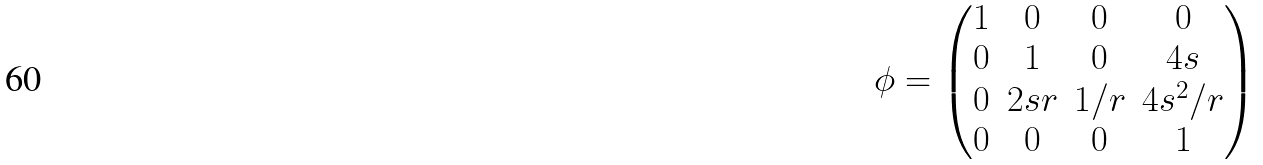Convert formula to latex. <formula><loc_0><loc_0><loc_500><loc_500>\phi = \begin{pmatrix} 1 & 0 & 0 & 0 \\ 0 & 1 & 0 & 4 s \\ 0 & 2 s r & 1 / r & 4 s ^ { 2 } / r \\ 0 & 0 & 0 & 1 \end{pmatrix}</formula> 